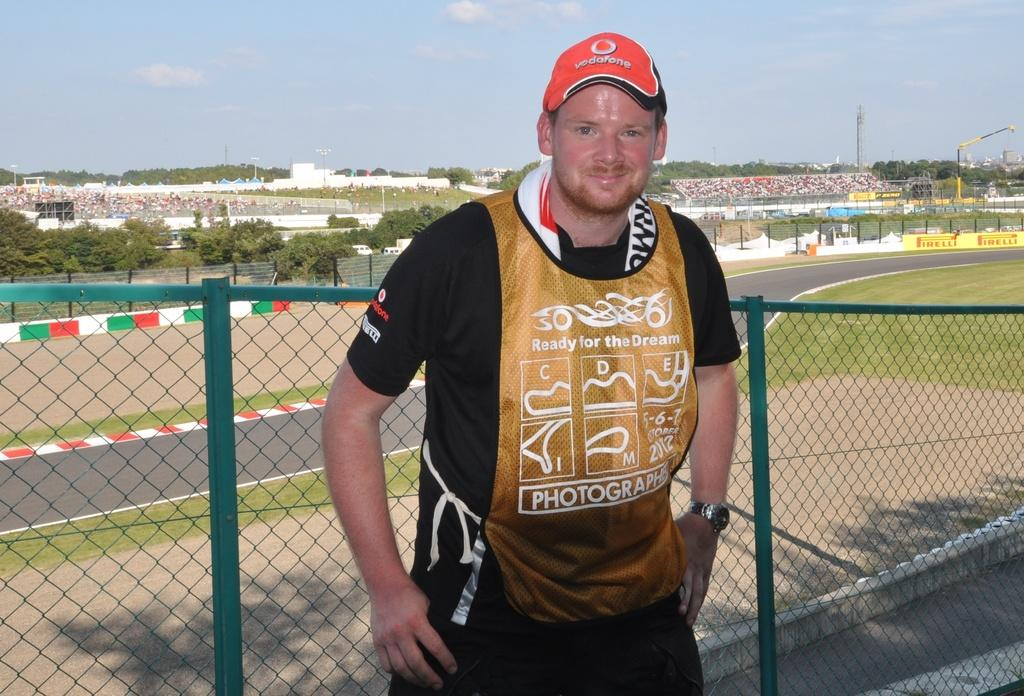<image>
Relay a brief, clear account of the picture shown. We can see a young fellow, wearing a red, photographer vest and a red, baseball cap. 